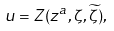Convert formula to latex. <formula><loc_0><loc_0><loc_500><loc_500>u = Z ( z ^ { a } , \zeta , \widetilde { \zeta } ) ,</formula> 